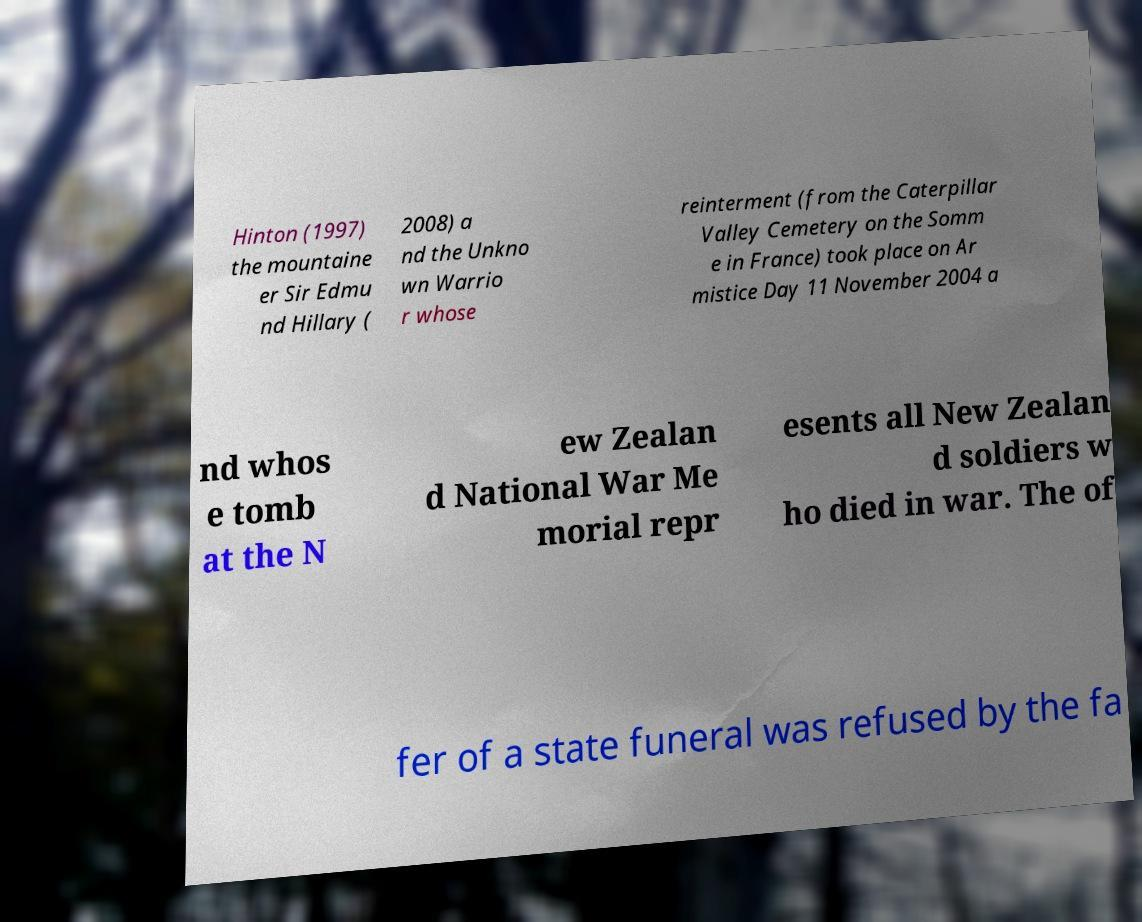For documentation purposes, I need the text within this image transcribed. Could you provide that? Hinton (1997) the mountaine er Sir Edmu nd Hillary ( 2008) a nd the Unkno wn Warrio r whose reinterment (from the Caterpillar Valley Cemetery on the Somm e in France) took place on Ar mistice Day 11 November 2004 a nd whos e tomb at the N ew Zealan d National War Me morial repr esents all New Zealan d soldiers w ho died in war. The of fer of a state funeral was refused by the fa 